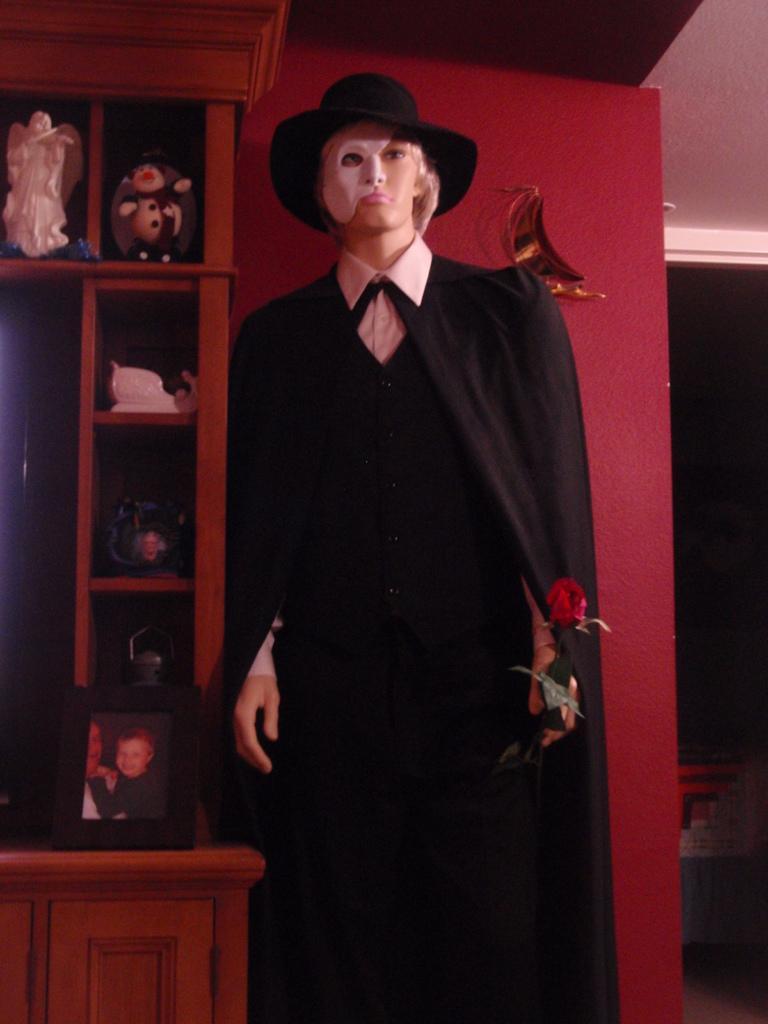Please provide a concise description of this image. This picture consists of mannequin which is holding a rose flower and In the background I can see a cupboard , in cupboards I can see shelves, in shelves I can see toys , in front of shelves I can see photo frame kept on table on the right side. 